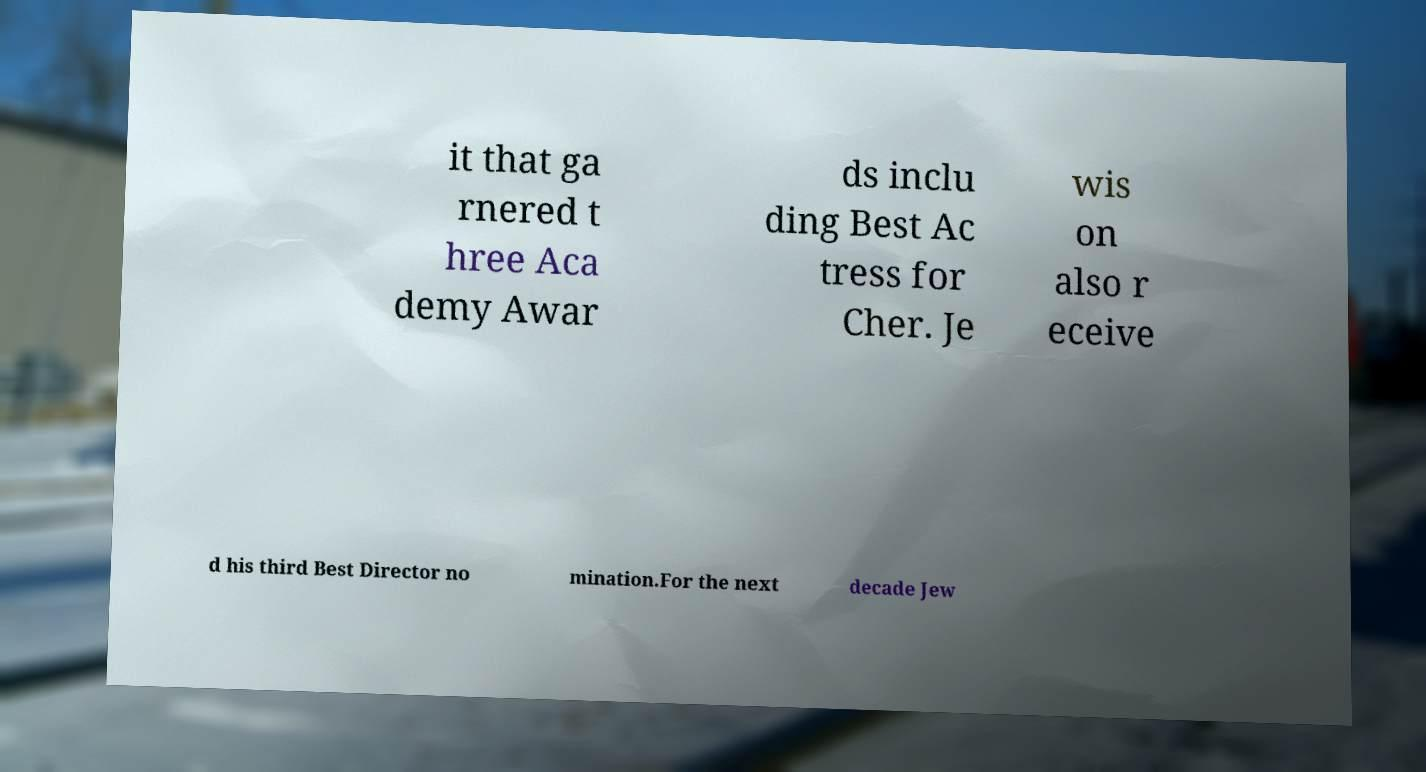Can you accurately transcribe the text from the provided image for me? it that ga rnered t hree Aca demy Awar ds inclu ding Best Ac tress for Cher. Je wis on also r eceive d his third Best Director no mination.For the next decade Jew 